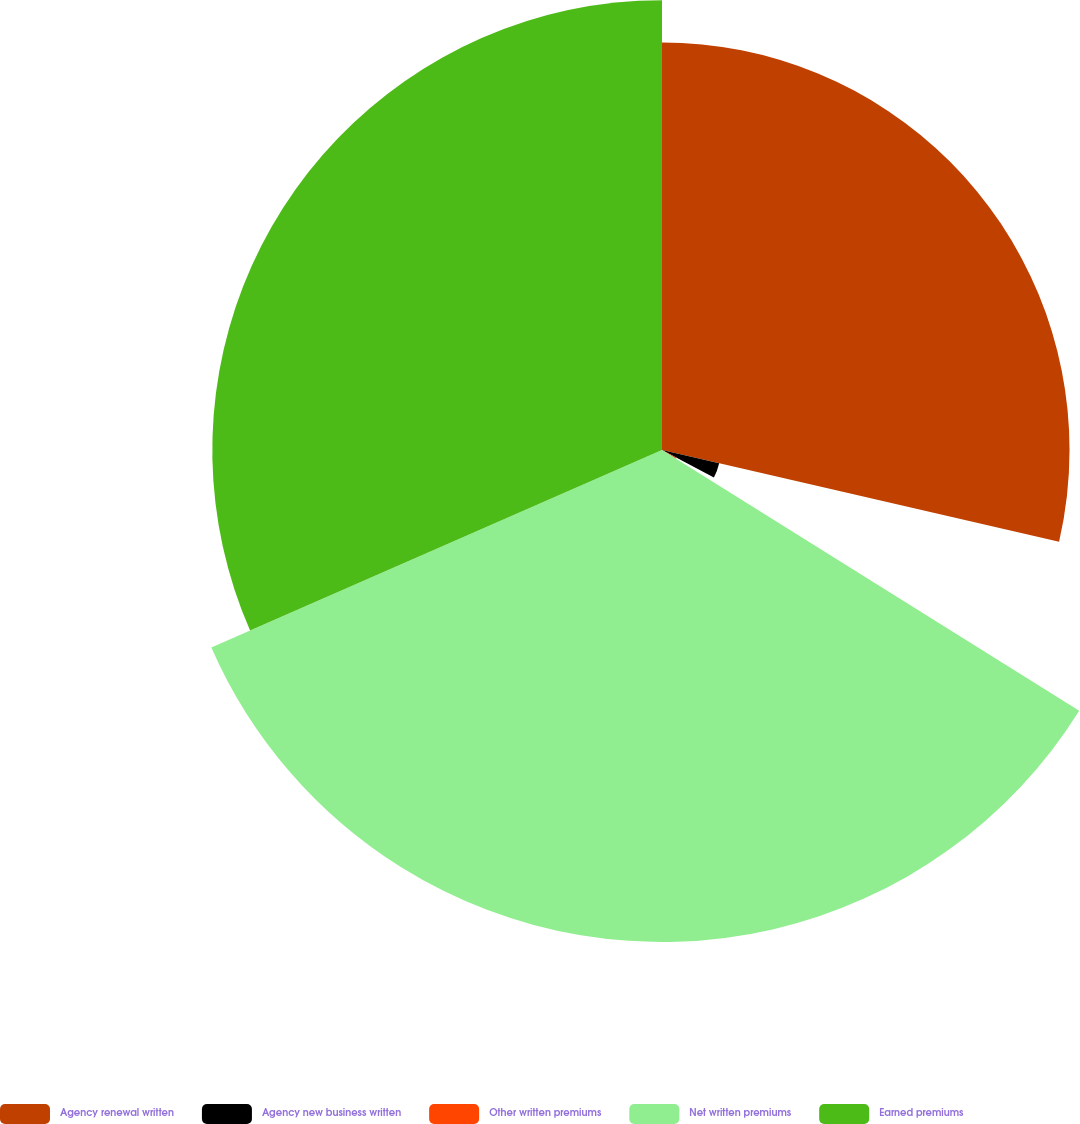Convert chart. <chart><loc_0><loc_0><loc_500><loc_500><pie_chart><fcel>Agency renewal written<fcel>Agency new business written<fcel>Other written premiums<fcel>Net written premiums<fcel>Earned premiums<nl><fcel>28.61%<fcel>4.12%<fcel>1.16%<fcel>34.54%<fcel>31.57%<nl></chart> 